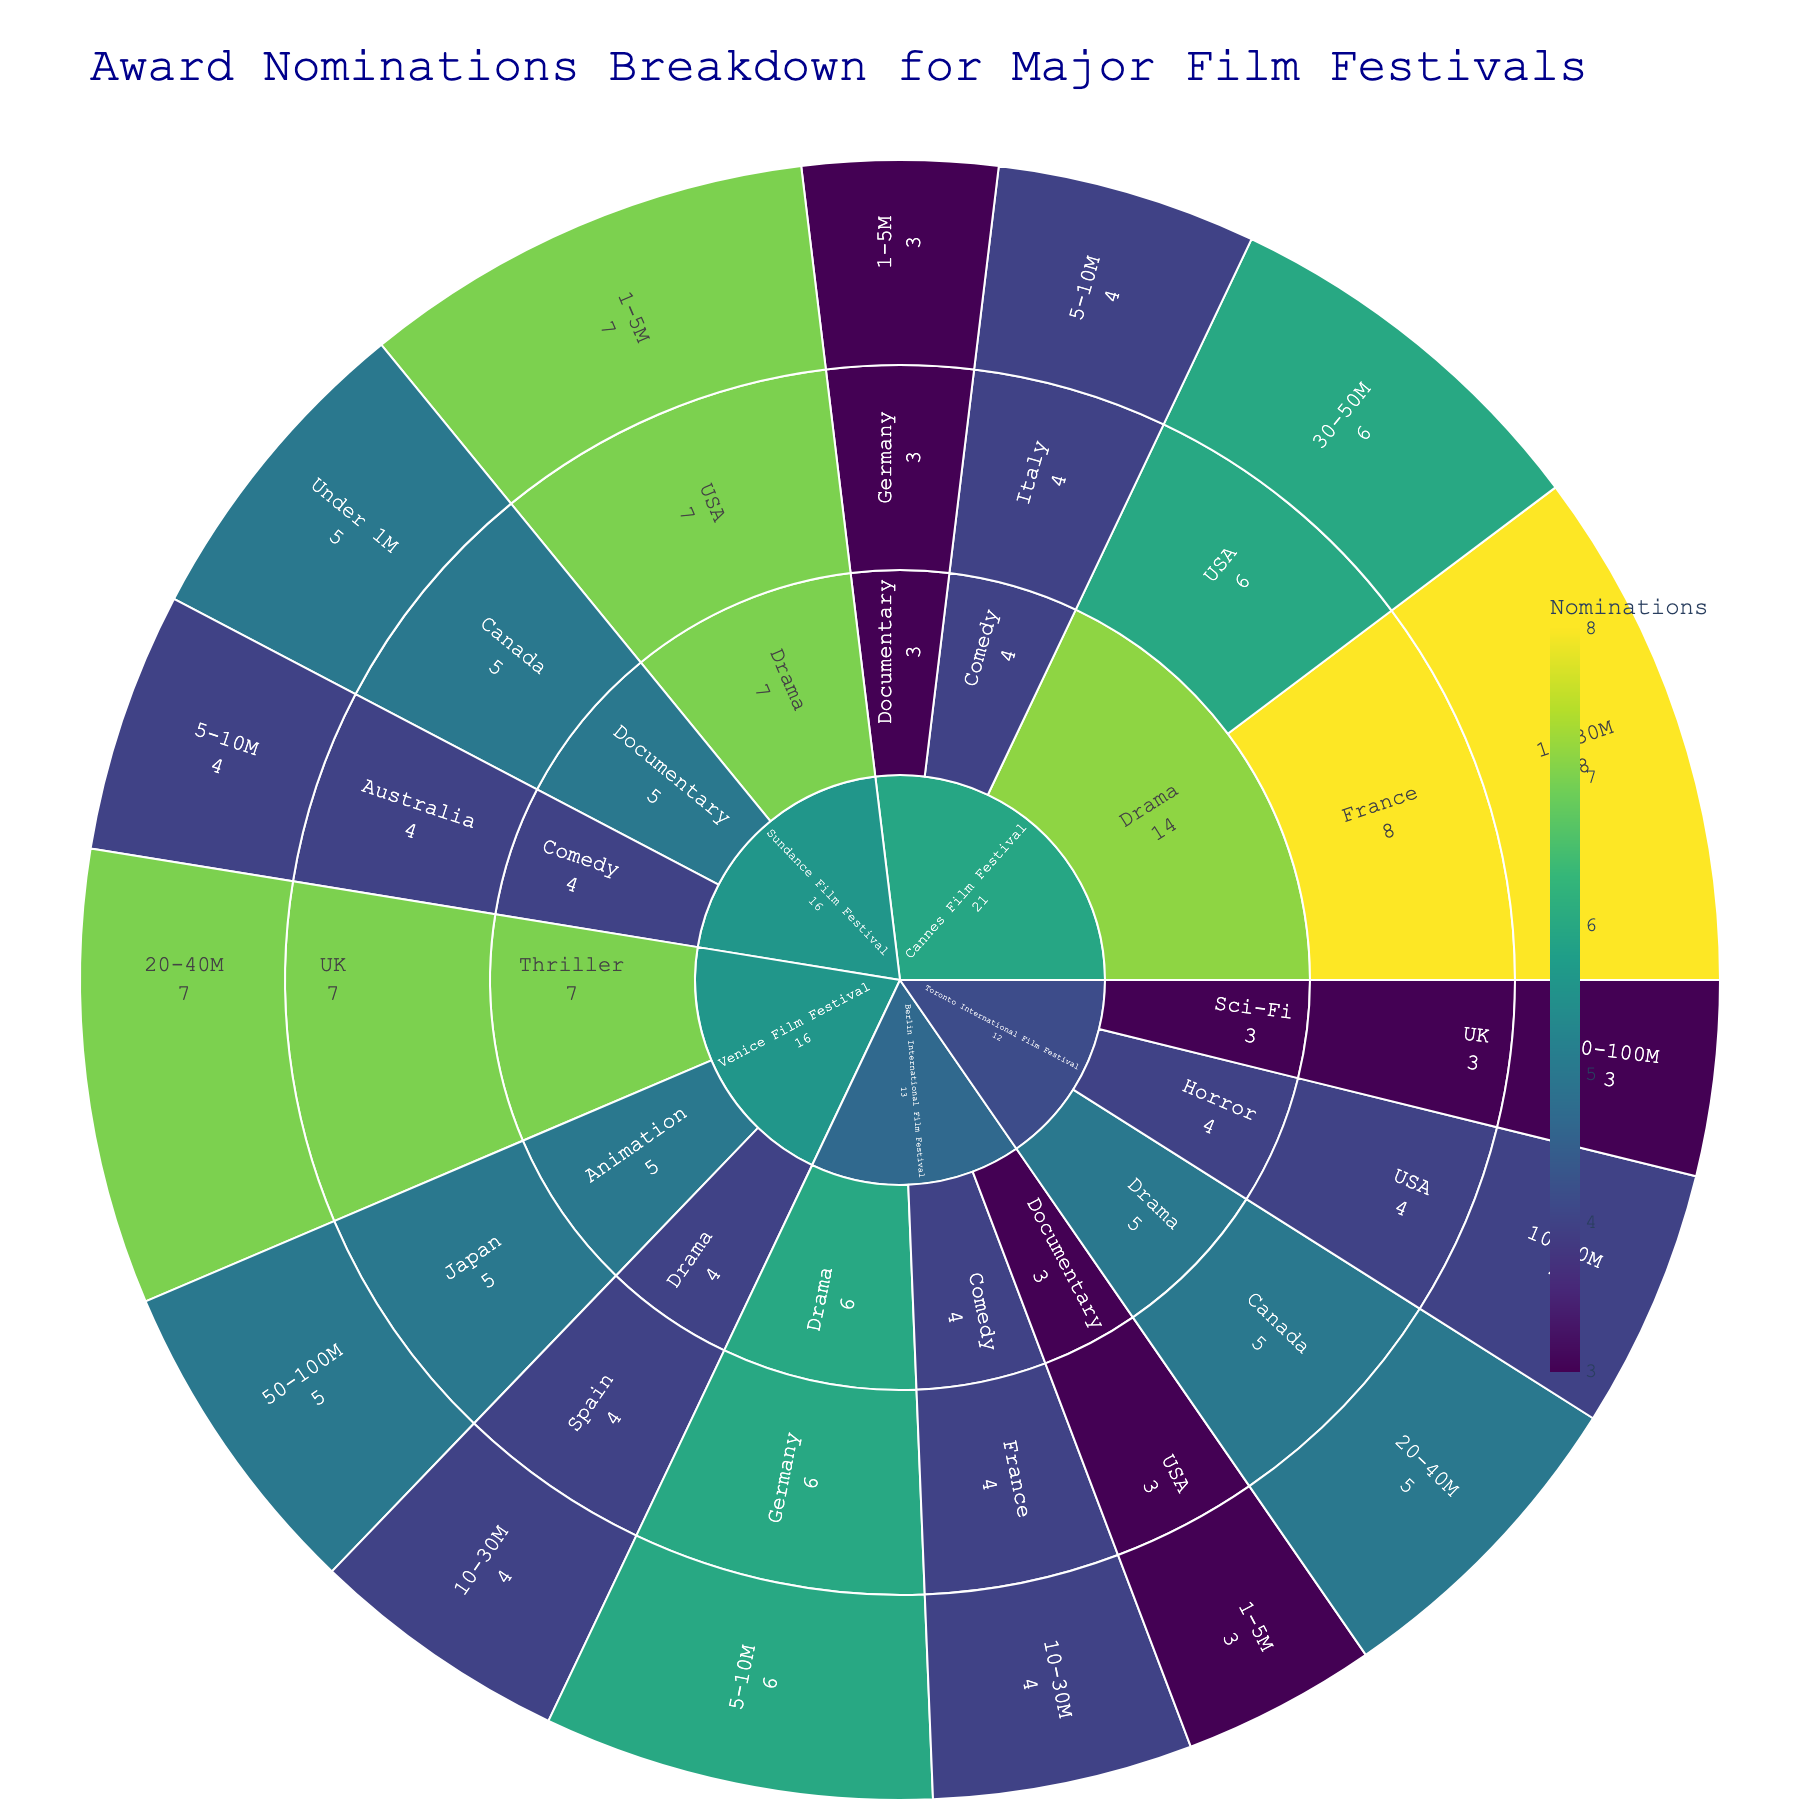Who has the most nominations for Drama films at the Cannes Film Festival and what is their budget range? First, look at the Cannes Film Festival section. Within that, find Drama films and check the country with the most nominations. Then, identify the budget range for that country. France has the most Drama nominations with 8, and the range is 10-30M.
Answer: France with a budget of 10-30M Which film festival has the highest total nominations for Documentary films? Identify all segments of the sunburst plot associated with Documentary films. Sum the nominations for each film festival and find the one with the greatest total. Sundance Film Festival has 5 nominations, Cannes Film Festival has 3, Berlin International Film Festival has 3, and Toronto International Film Festival has none.
Answer: Sundance Film Festival Between France and Germany, which country has more total nominations across all film types in the Berlin International Film Festival? Look at the sub-segments within the Berlin International Film Festival for Germany (Drama and Documentary) and France (Comedy). Total the nominations. France nominations: 4. Germany nominations: 6.
Answer: Germany What is the total number of nominations for films with a budget range of 1-5M? Locate all sub-segments in the plot with a budget range of 1-5M. Sum the nominations. Cannes Film Festival (3), Berlin International Film Festival (3), Sundance Film Festival (7).
Answer: 13 How many nominations does Japan have for Animation films at the Venice Film Festival? Within the Venice Film Festival segment, locate the Animation type and find Japan. The segment shows that Japan has 5 nominations for Animation films.
Answer: 5 Which country has more nominations for Drama films at the Sundance Film Festival, and what are their respective nomination counts? Look at the Drama segment within the Sundance Film Festival. Compare the nominations for USA and any other country present. USA has 7 nominations, no other country is listed for Drama.
Answer: USA (7) Compare the nominations for Comedy films between the Berlin International Film Festival and the Sundance Film Festival. Which festival has more, and by how much? Locate the Comedy segments within both festivals and compare their nominations. Berlin has 4, Sundance has 4. The difference is 0.
Answer: Equal, 0 difference What is the budget range for the highest nominated Sci-Fi film, and which festival does it belong to? Look for the segment with Sci-Fi films. Identify the festival and budget range with the highest nominations. The Toronto International Film Festival Sci-Fi segment shows 3 nominations with a budget range of 50-100M.
Answer: 50-100M, Toronto International Film Festival 